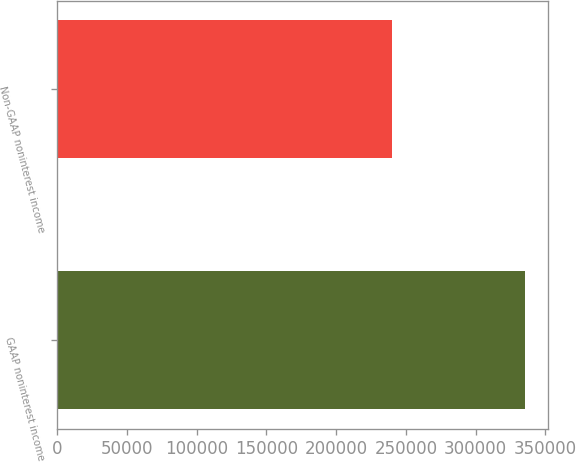<chart> <loc_0><loc_0><loc_500><loc_500><bar_chart><fcel>GAAP noninterest income<fcel>Non-GAAP noninterest income<nl><fcel>335546<fcel>240408<nl></chart> 